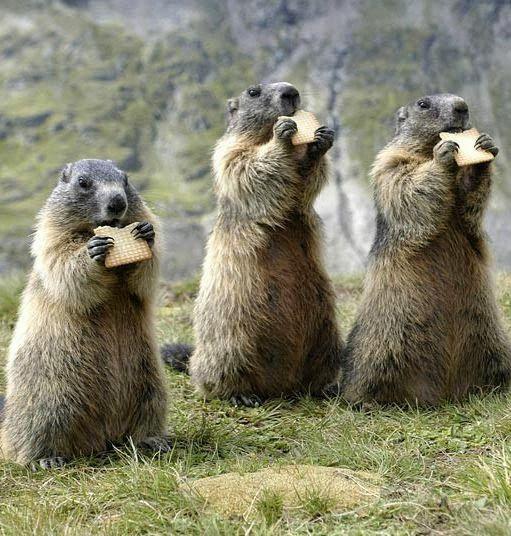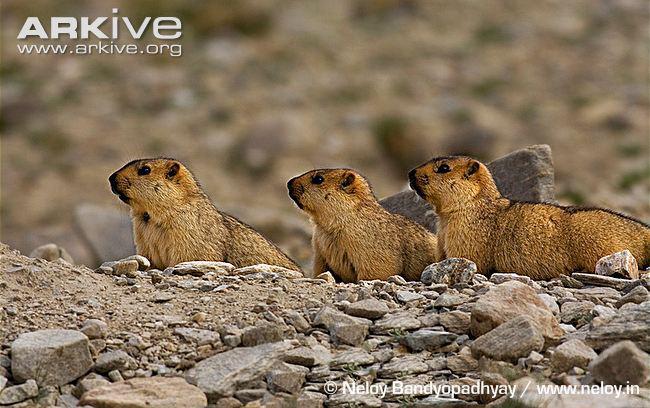The first image is the image on the left, the second image is the image on the right. For the images shown, is this caption "At least three marmots are eating." true? Answer yes or no. Yes. The first image is the image on the left, the second image is the image on the right. Given the left and right images, does the statement "The left and right image contains the same number of prairie dogs." hold true? Answer yes or no. Yes. 